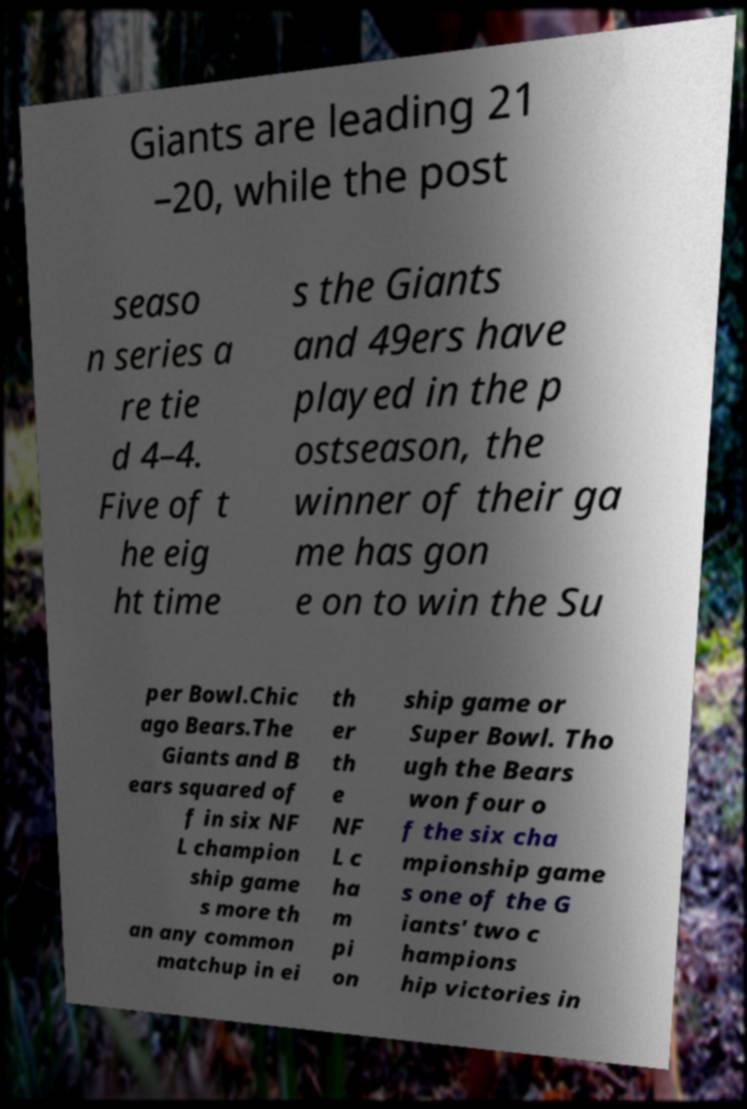For documentation purposes, I need the text within this image transcribed. Could you provide that? Giants are leading 21 –20, while the post seaso n series a re tie d 4–4. Five of t he eig ht time s the Giants and 49ers have played in the p ostseason, the winner of their ga me has gon e on to win the Su per Bowl.Chic ago Bears.The Giants and B ears squared of f in six NF L champion ship game s more th an any common matchup in ei th er th e NF L c ha m pi on ship game or Super Bowl. Tho ugh the Bears won four o f the six cha mpionship game s one of the G iants' two c hampions hip victories in 